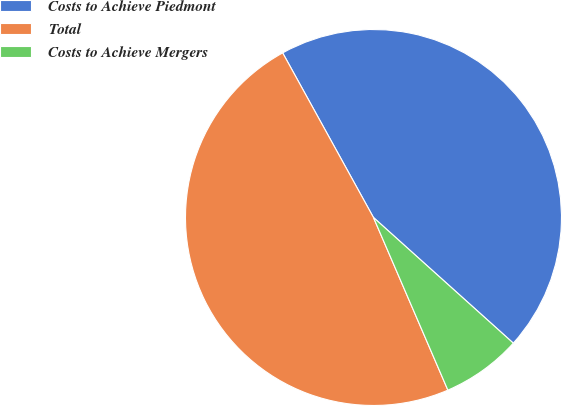Convert chart. <chart><loc_0><loc_0><loc_500><loc_500><pie_chart><fcel>Costs to Achieve Piedmont<fcel>Total<fcel>Costs to Achieve Mergers<nl><fcel>44.67%<fcel>48.45%<fcel>6.87%<nl></chart> 